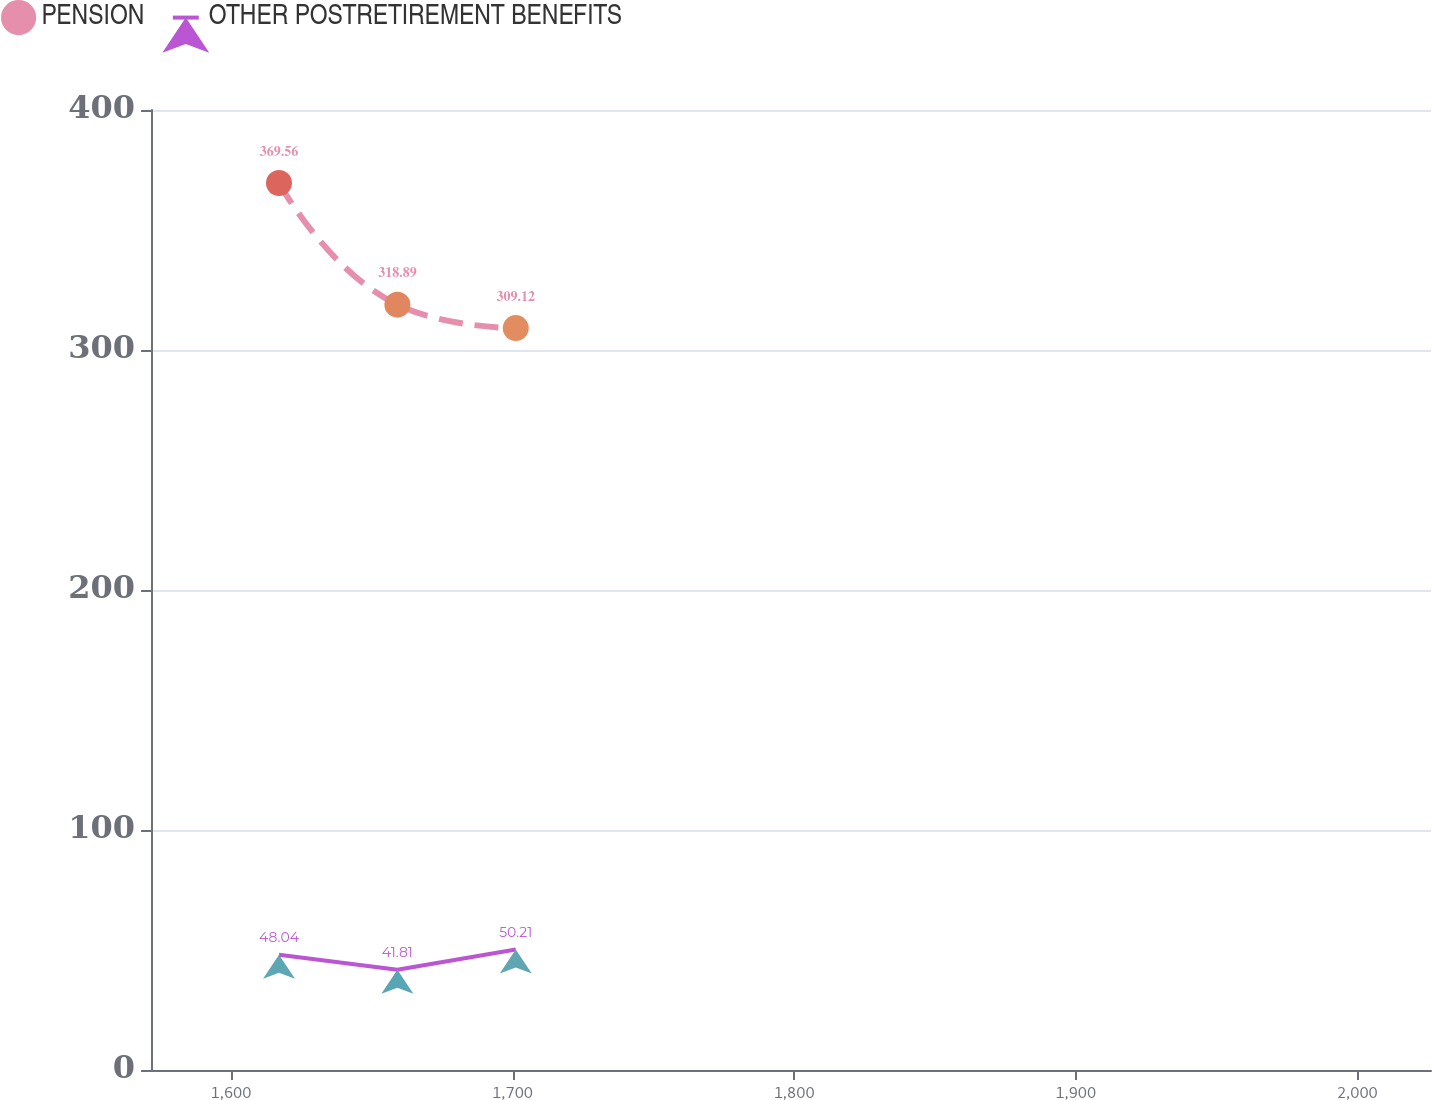Convert chart to OTSL. <chart><loc_0><loc_0><loc_500><loc_500><line_chart><ecel><fcel>PENSION<fcel>OTHER POSTRETIREMENT BENEFITS<nl><fcel>1617.06<fcel>369.56<fcel>48.04<nl><fcel>1659.1<fcel>318.89<fcel>41.81<nl><fcel>1701.14<fcel>309.12<fcel>50.21<nl><fcel>2029.6<fcel>344<fcel>36.92<nl><fcel>2071.64<fcel>406.85<fcel>32.37<nl></chart> 